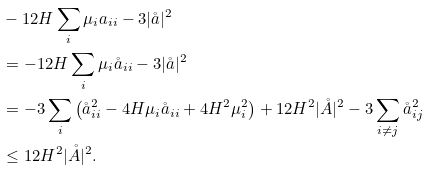Convert formula to latex. <formula><loc_0><loc_0><loc_500><loc_500>& - 1 2 H \sum _ { i } \mu _ { i } a _ { i i } - 3 | \mathring { a } | ^ { 2 } \\ & = - 1 2 H \sum _ { i } \mu _ { i } \mathring { a } _ { i i } - 3 | \mathring { a } | ^ { 2 } \\ & = - 3 \sum _ { i } \left ( \mathring { a } _ { i i } ^ { 2 } - 4 H \mu _ { i } \mathring { a } _ { i i } + 4 H ^ { 2 } \mu _ { i } ^ { 2 } \right ) + 1 2 H ^ { 2 } | \mathring { A } | ^ { 2 } - 3 \sum _ { i \neq j } \mathring { a } _ { i j } ^ { 2 } \\ & \leq 1 2 H ^ { 2 } | \mathring { A } | ^ { 2 } .</formula> 